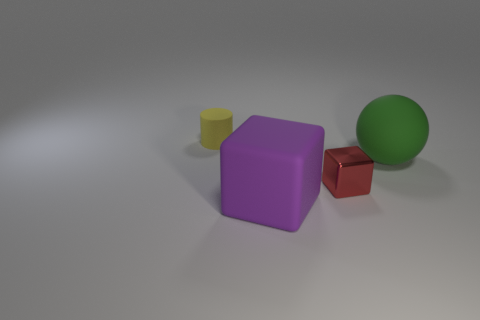Does the tiny object that is in front of the small yellow rubber cylinder have the same material as the object in front of the tiny block?
Your answer should be compact. No. The block that is in front of the tiny object to the right of the tiny cylinder is made of what material?
Make the answer very short. Rubber. The big thing that is left of the thing that is on the right side of the small thing that is right of the small yellow rubber thing is what shape?
Ensure brevity in your answer.  Cube. There is another object that is the same shape as the red shiny object; what is it made of?
Offer a terse response. Rubber. What number of matte cubes are there?
Give a very brief answer. 1. What shape is the big object on the right side of the metallic block?
Provide a short and direct response. Sphere. The big thing in front of the small object to the right of the tiny thing that is to the left of the small red metal cube is what color?
Keep it short and to the point. Purple. What is the shape of the tiny yellow thing that is the same material as the ball?
Provide a succinct answer. Cylinder. Are there fewer yellow cylinders than big gray matte balls?
Make the answer very short. No. Is the green ball made of the same material as the red thing?
Offer a terse response. No. 